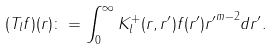<formula> <loc_0><loc_0><loc_500><loc_500>( T _ { l } f ) ( r ) \colon = \int _ { 0 } ^ { \infty } K _ { l } ^ { + } ( r , r ^ { \prime } ) f ( r ^ { \prime } ) { r ^ { \prime } } ^ { m - 2 } d r ^ { \prime } .</formula> 